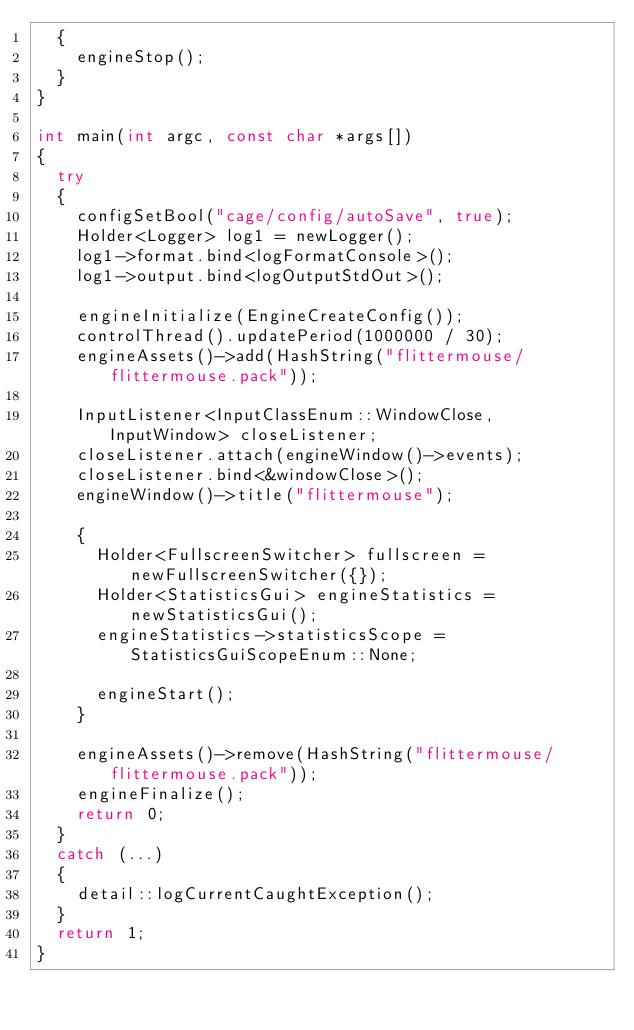Convert code to text. <code><loc_0><loc_0><loc_500><loc_500><_C++_>	{
		engineStop();
	}
}

int main(int argc, const char *args[])
{
	try
	{
		configSetBool("cage/config/autoSave", true);
		Holder<Logger> log1 = newLogger();
		log1->format.bind<logFormatConsole>();
		log1->output.bind<logOutputStdOut>();

		engineInitialize(EngineCreateConfig());
		controlThread().updatePeriod(1000000 / 30);
		engineAssets()->add(HashString("flittermouse/flittermouse.pack"));

		InputListener<InputClassEnum::WindowClose, InputWindow> closeListener;
		closeListener.attach(engineWindow()->events);
		closeListener.bind<&windowClose>();
		engineWindow()->title("flittermouse");

		{
			Holder<FullscreenSwitcher> fullscreen = newFullscreenSwitcher({});
			Holder<StatisticsGui> engineStatistics = newStatisticsGui();
			engineStatistics->statisticsScope = StatisticsGuiScopeEnum::None;

			engineStart();
		}

		engineAssets()->remove(HashString("flittermouse/flittermouse.pack"));
		engineFinalize();
		return 0;
	}
	catch (...)
	{
		detail::logCurrentCaughtException();
	}
	return 1;
}
</code> 